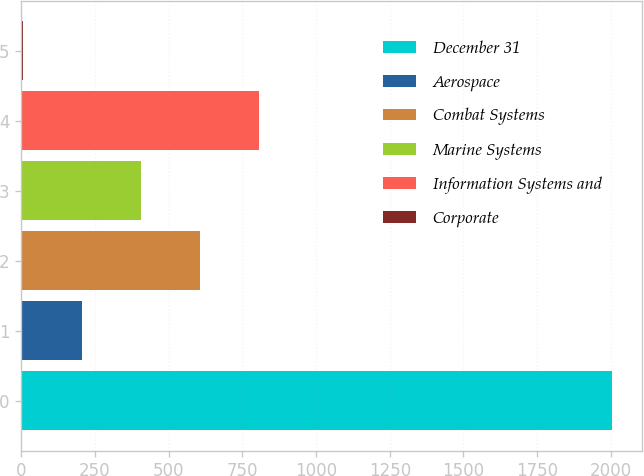Convert chart. <chart><loc_0><loc_0><loc_500><loc_500><bar_chart><fcel>December 31<fcel>Aerospace<fcel>Combat Systems<fcel>Marine Systems<fcel>Information Systems and<fcel>Corporate<nl><fcel>2005<fcel>205<fcel>605<fcel>405<fcel>805<fcel>5<nl></chart> 